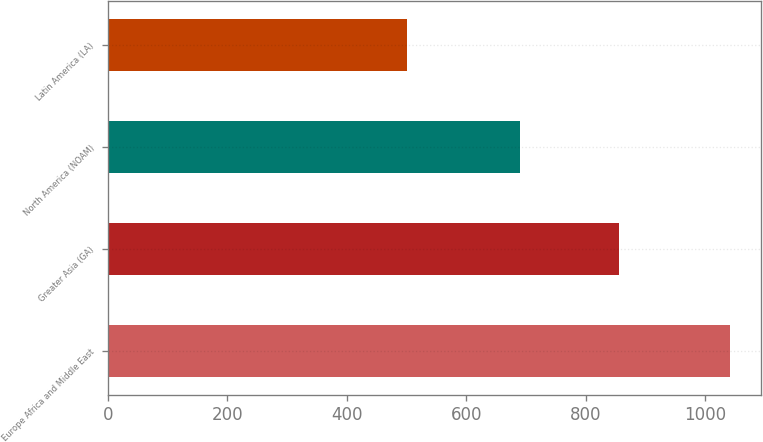Convert chart. <chart><loc_0><loc_0><loc_500><loc_500><bar_chart><fcel>Europe Africa and Middle East<fcel>Greater Asia (GA)<fcel>North America (NOAM)<fcel>Latin America (LA)<nl><fcel>1042<fcel>856<fcel>690<fcel>501<nl></chart> 